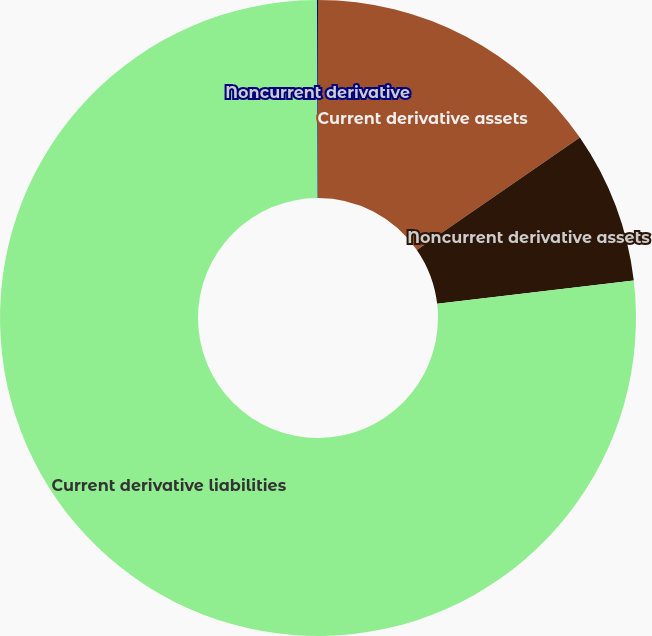Convert chart. <chart><loc_0><loc_0><loc_500><loc_500><pie_chart><fcel>Current derivative assets<fcel>Noncurrent derivative assets<fcel>Current derivative liabilities<fcel>Noncurrent derivative<nl><fcel>15.4%<fcel>7.72%<fcel>76.83%<fcel>0.05%<nl></chart> 